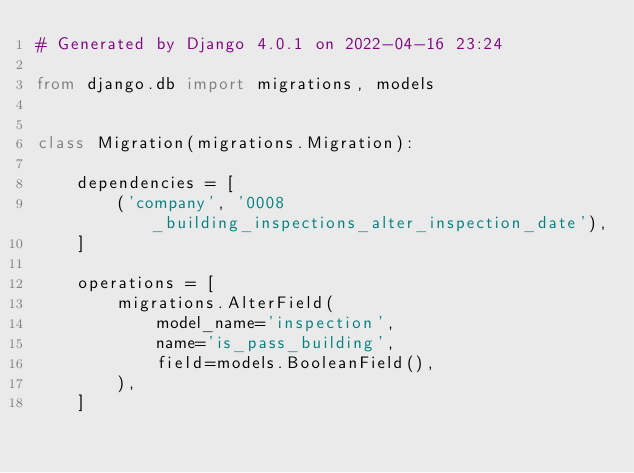Convert code to text. <code><loc_0><loc_0><loc_500><loc_500><_Python_># Generated by Django 4.0.1 on 2022-04-16 23:24

from django.db import migrations, models


class Migration(migrations.Migration):

    dependencies = [
        ('company', '0008_building_inspections_alter_inspection_date'),
    ]

    operations = [
        migrations.AlterField(
            model_name='inspection',
            name='is_pass_building',
            field=models.BooleanField(),
        ),
    ]
</code> 